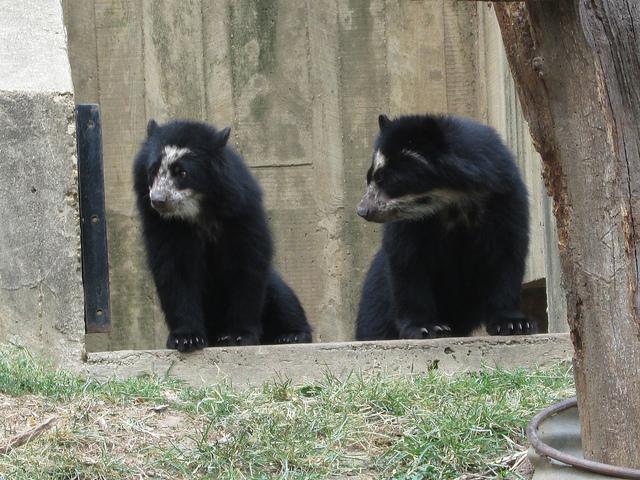How many animals are there?
Answer briefly. 2. What kind of animals are in the picture?
Give a very brief answer. Bears. What is in front of the animals?
Keep it brief. Tree. 